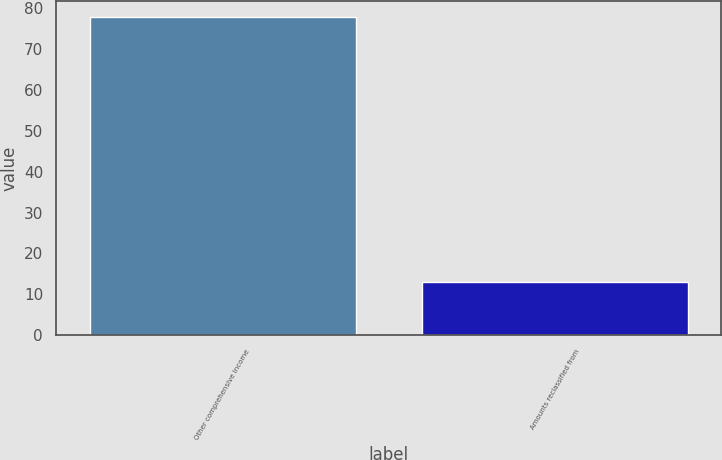Convert chart. <chart><loc_0><loc_0><loc_500><loc_500><bar_chart><fcel>Other comprehensive income<fcel>Amounts reclassified from<nl><fcel>78<fcel>13<nl></chart> 